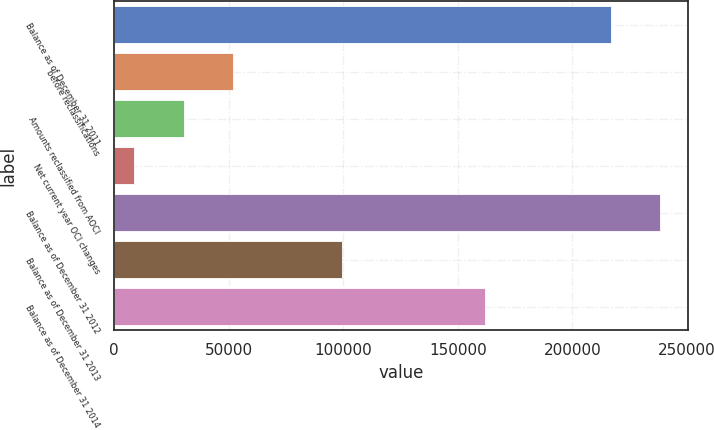Convert chart to OTSL. <chart><loc_0><loc_0><loc_500><loc_500><bar_chart><fcel>Balance as of December 31 2011<fcel>before reclassifications<fcel>Amounts reclassified from AOCI<fcel>Net current year OCI changes<fcel>Balance as of December 31 2012<fcel>Balance as of December 31 2013<fcel>Balance as of December 31 2014<nl><fcel>216844<fcel>52041.8<fcel>30357.4<fcel>8673<fcel>238528<fcel>99631<fcel>161714<nl></chart> 